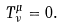<formula> <loc_0><loc_0><loc_500><loc_500>T ^ { \mu } _ { \nu } = 0 .</formula> 